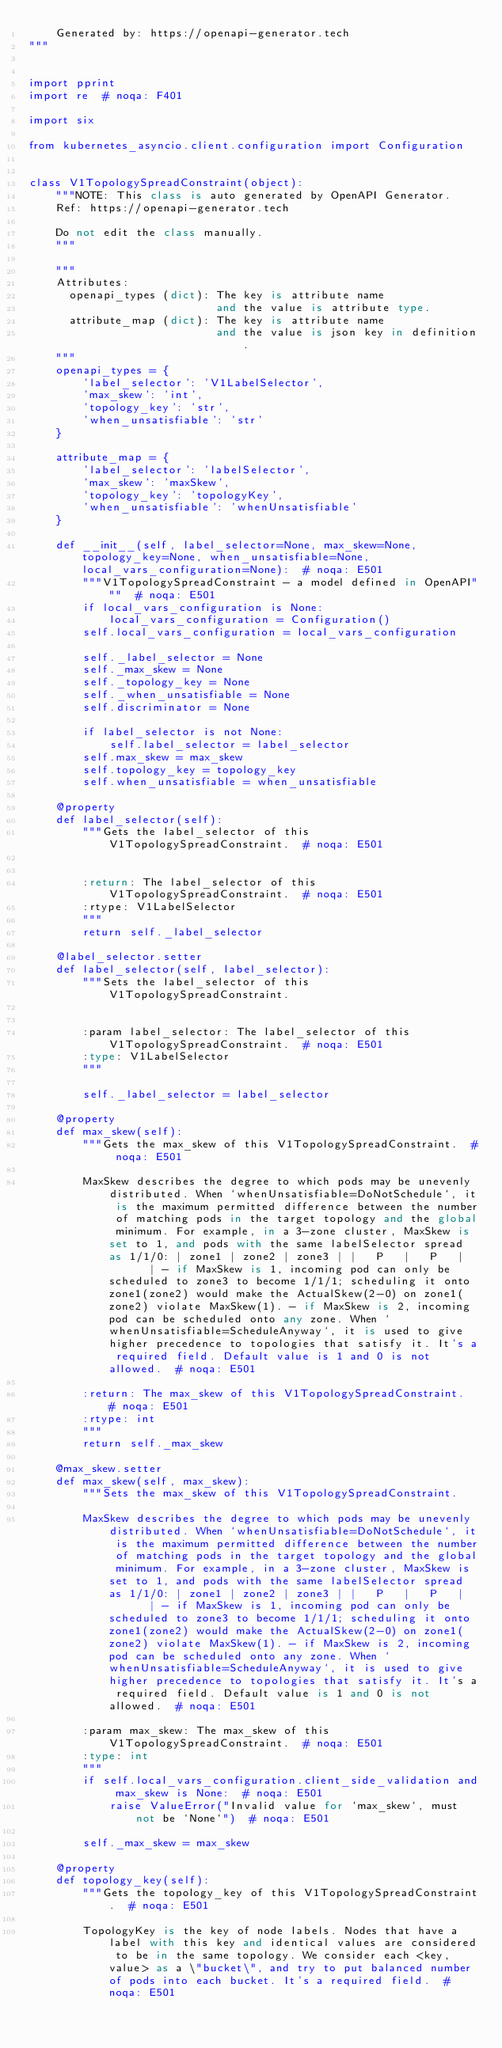<code> <loc_0><loc_0><loc_500><loc_500><_Python_>    Generated by: https://openapi-generator.tech
"""


import pprint
import re  # noqa: F401

import six

from kubernetes_asyncio.client.configuration import Configuration


class V1TopologySpreadConstraint(object):
    """NOTE: This class is auto generated by OpenAPI Generator.
    Ref: https://openapi-generator.tech

    Do not edit the class manually.
    """

    """
    Attributes:
      openapi_types (dict): The key is attribute name
                            and the value is attribute type.
      attribute_map (dict): The key is attribute name
                            and the value is json key in definition.
    """
    openapi_types = {
        'label_selector': 'V1LabelSelector',
        'max_skew': 'int',
        'topology_key': 'str',
        'when_unsatisfiable': 'str'
    }

    attribute_map = {
        'label_selector': 'labelSelector',
        'max_skew': 'maxSkew',
        'topology_key': 'topologyKey',
        'when_unsatisfiable': 'whenUnsatisfiable'
    }

    def __init__(self, label_selector=None, max_skew=None, topology_key=None, when_unsatisfiable=None, local_vars_configuration=None):  # noqa: E501
        """V1TopologySpreadConstraint - a model defined in OpenAPI"""  # noqa: E501
        if local_vars_configuration is None:
            local_vars_configuration = Configuration()
        self.local_vars_configuration = local_vars_configuration

        self._label_selector = None
        self._max_skew = None
        self._topology_key = None
        self._when_unsatisfiable = None
        self.discriminator = None

        if label_selector is not None:
            self.label_selector = label_selector
        self.max_skew = max_skew
        self.topology_key = topology_key
        self.when_unsatisfiable = when_unsatisfiable

    @property
    def label_selector(self):
        """Gets the label_selector of this V1TopologySpreadConstraint.  # noqa: E501


        :return: The label_selector of this V1TopologySpreadConstraint.  # noqa: E501
        :rtype: V1LabelSelector
        """
        return self._label_selector

    @label_selector.setter
    def label_selector(self, label_selector):
        """Sets the label_selector of this V1TopologySpreadConstraint.


        :param label_selector: The label_selector of this V1TopologySpreadConstraint.  # noqa: E501
        :type: V1LabelSelector
        """

        self._label_selector = label_selector

    @property
    def max_skew(self):
        """Gets the max_skew of this V1TopologySpreadConstraint.  # noqa: E501

        MaxSkew describes the degree to which pods may be unevenly distributed. When `whenUnsatisfiable=DoNotSchedule`, it is the maximum permitted difference between the number of matching pods in the target topology and the global minimum. For example, in a 3-zone cluster, MaxSkew is set to 1, and pods with the same labelSelector spread as 1/1/0: | zone1 | zone2 | zone3 | |   P   |   P   |       | - if MaxSkew is 1, incoming pod can only be scheduled to zone3 to become 1/1/1; scheduling it onto zone1(zone2) would make the ActualSkew(2-0) on zone1(zone2) violate MaxSkew(1). - if MaxSkew is 2, incoming pod can be scheduled onto any zone. When `whenUnsatisfiable=ScheduleAnyway`, it is used to give higher precedence to topologies that satisfy it. It's a required field. Default value is 1 and 0 is not allowed.  # noqa: E501

        :return: The max_skew of this V1TopologySpreadConstraint.  # noqa: E501
        :rtype: int
        """
        return self._max_skew

    @max_skew.setter
    def max_skew(self, max_skew):
        """Sets the max_skew of this V1TopologySpreadConstraint.

        MaxSkew describes the degree to which pods may be unevenly distributed. When `whenUnsatisfiable=DoNotSchedule`, it is the maximum permitted difference between the number of matching pods in the target topology and the global minimum. For example, in a 3-zone cluster, MaxSkew is set to 1, and pods with the same labelSelector spread as 1/1/0: | zone1 | zone2 | zone3 | |   P   |   P   |       | - if MaxSkew is 1, incoming pod can only be scheduled to zone3 to become 1/1/1; scheduling it onto zone1(zone2) would make the ActualSkew(2-0) on zone1(zone2) violate MaxSkew(1). - if MaxSkew is 2, incoming pod can be scheduled onto any zone. When `whenUnsatisfiable=ScheduleAnyway`, it is used to give higher precedence to topologies that satisfy it. It's a required field. Default value is 1 and 0 is not allowed.  # noqa: E501

        :param max_skew: The max_skew of this V1TopologySpreadConstraint.  # noqa: E501
        :type: int
        """
        if self.local_vars_configuration.client_side_validation and max_skew is None:  # noqa: E501
            raise ValueError("Invalid value for `max_skew`, must not be `None`")  # noqa: E501

        self._max_skew = max_skew

    @property
    def topology_key(self):
        """Gets the topology_key of this V1TopologySpreadConstraint.  # noqa: E501

        TopologyKey is the key of node labels. Nodes that have a label with this key and identical values are considered to be in the same topology. We consider each <key, value> as a \"bucket\", and try to put balanced number of pods into each bucket. It's a required field.  # noqa: E501
</code> 